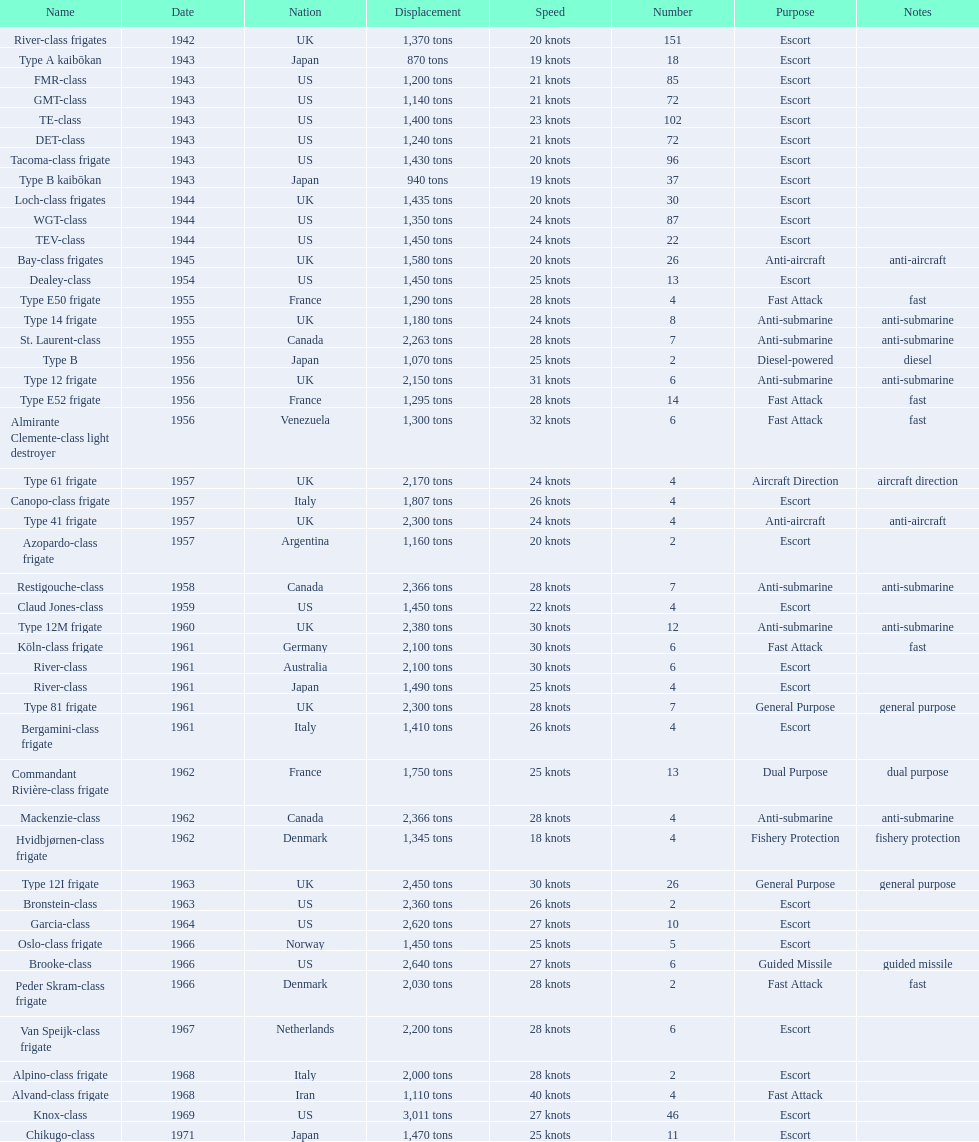In 1968 italy used alpino-class frigate. what was its top speed? 28 knots. 